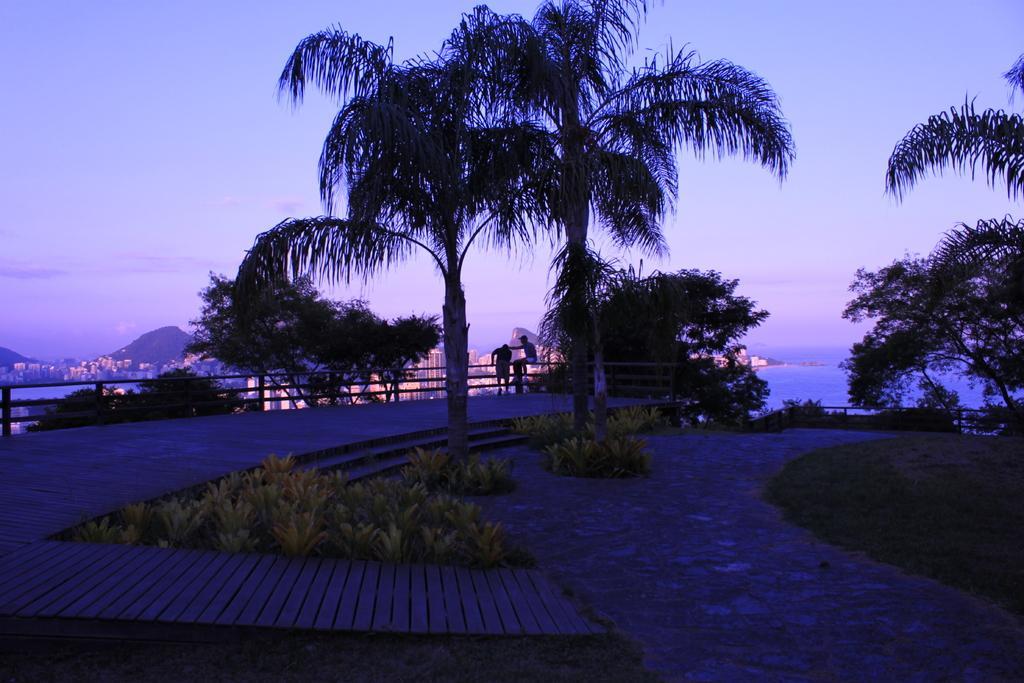Can you describe this image briefly? In this picture I can see few trees and plants and I can see a man standing and another man seated on the metal fence and I can see buildings, water and a cloudy sky. 